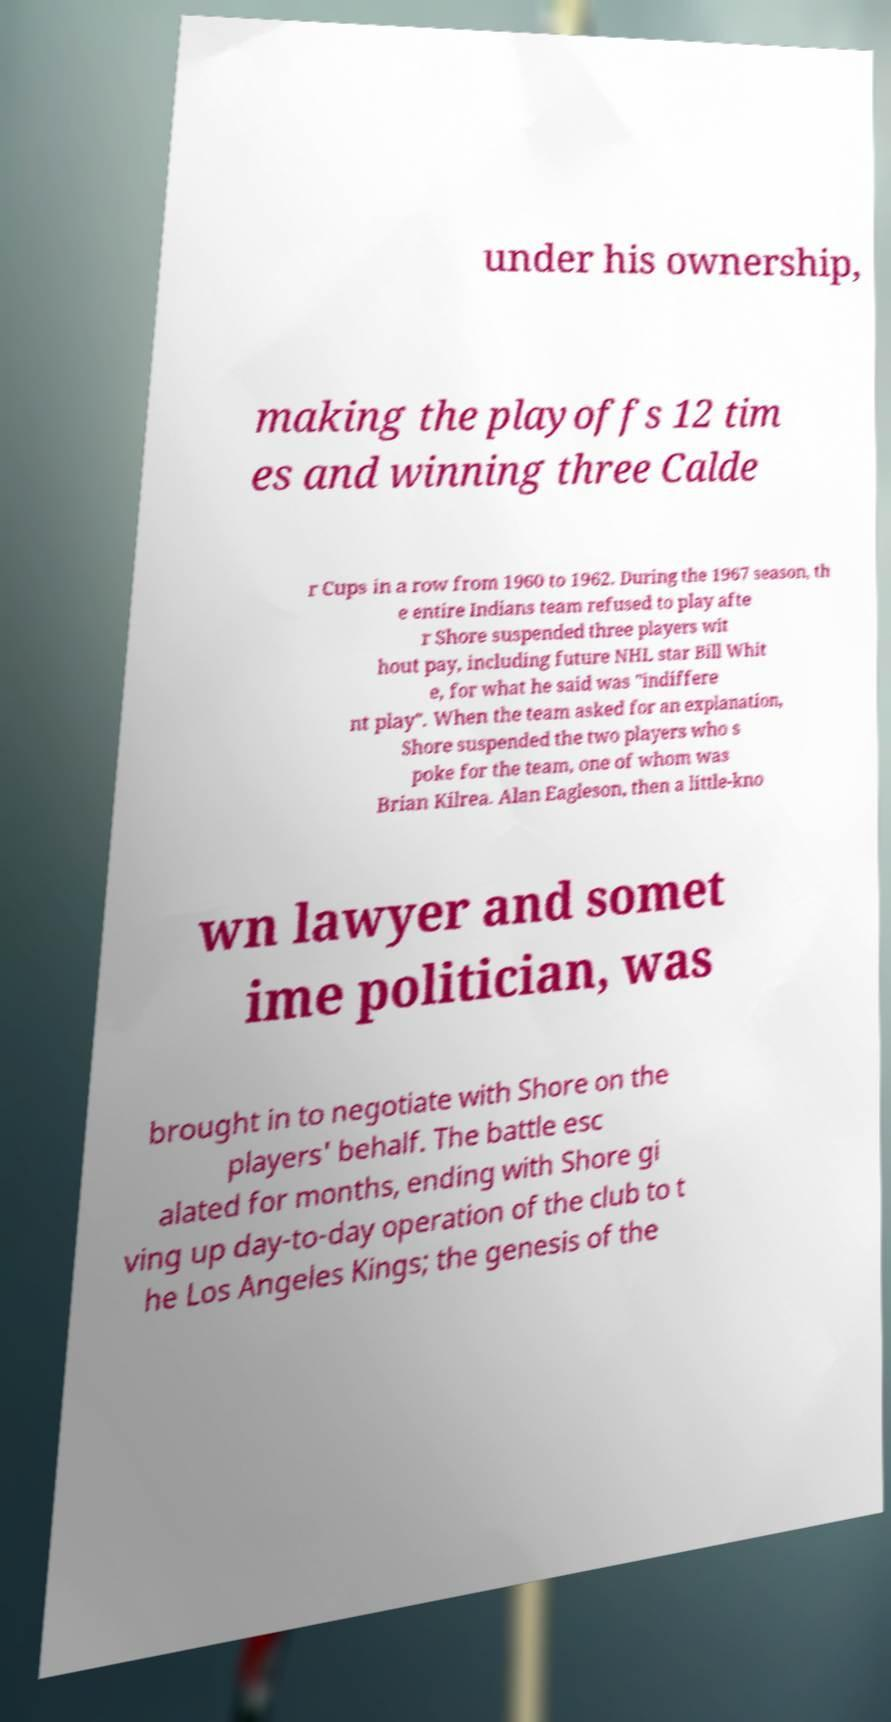I need the written content from this picture converted into text. Can you do that? under his ownership, making the playoffs 12 tim es and winning three Calde r Cups in a row from 1960 to 1962. During the 1967 season, th e entire Indians team refused to play afte r Shore suspended three players wit hout pay, including future NHL star Bill Whit e, for what he said was "indiffere nt play". When the team asked for an explanation, Shore suspended the two players who s poke for the team, one of whom was Brian Kilrea. Alan Eagleson, then a little-kno wn lawyer and somet ime politician, was brought in to negotiate with Shore on the players' behalf. The battle esc alated for months, ending with Shore gi ving up day-to-day operation of the club to t he Los Angeles Kings; the genesis of the 